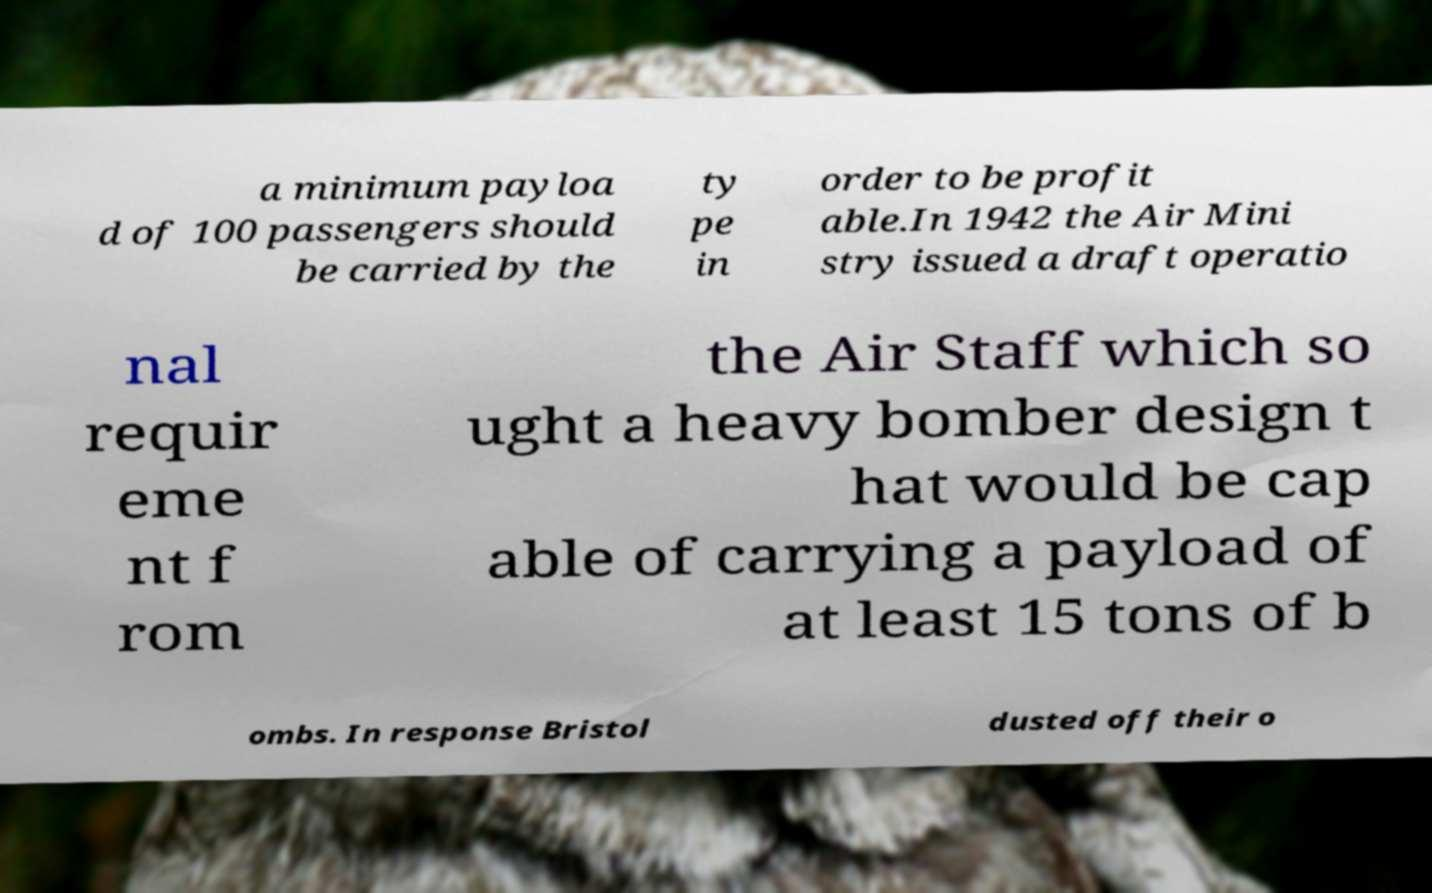What messages or text are displayed in this image? I need them in a readable, typed format. a minimum payloa d of 100 passengers should be carried by the ty pe in order to be profit able.In 1942 the Air Mini stry issued a draft operatio nal requir eme nt f rom the Air Staff which so ught a heavy bomber design t hat would be cap able of carrying a payload of at least 15 tons of b ombs. In response Bristol dusted off their o 